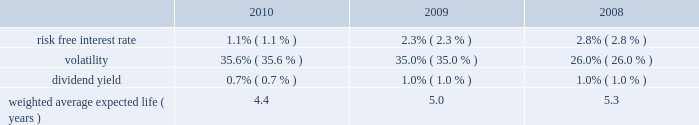The weighted average fair value of options granted during 2010 , 2009 and 2008 was estimated to be $ 7.84 , $ 7.18 and $ 3.84 , respectively , using the black-scholes option pricing model with the assumptions below: .
At december 31 , 2010 and 2009 , the total unrecognized compensation cost related to non-vested stock awards is $ 129.3 million and $ 93.5 million , respectively , which is expected to be recognized in pre-tax income over a weighted average period of 1.7 years as of both year ends .
The company granted a total of 1.5 million restricted stock awards at prices ranging from $ 25.76 to $ 28.15 on various dates in 2010 .
These awards vest annually over three years .
The company also granted 0.9 million performance restricted stock units during 2010 .
These performance restricted stock units have been granted at the maximum achievable level and the number of shares that can vest is based on specific revenue and ebitda goals for periods from 2010 through 2012 .
During 2009 , we granted 0.5 million shares of restricted stock at a price of $ 22.55 that vest annually over 3 years .
On october 1 , 2009 , the company granted 0.4 million restricted stock units at a price of $ 24.85 per share that vested over six months .
On march 20 , 2008 , we granted 0.4 million shares of restricted stock at a price of $ 38.75 that were to vest quarterly over 2 years .
On july 2 , 2008 , 0.2 million of these shares were canceled and assumed by lps .
The remaining unvested restricted shares were converted by the conversion factor of 1.7952 .
These awards vested as of october 1 , 2009 , under the change in control provisions due to the metavante acquisition .
On october 27 , 2008 , we granted 0.8 million shares of restricted stock at a price of $ 14.35 that vest annually over 3 years .
As of december 31 , 2010 and 2009 , we have approximately 2.2 million and 1.4 million unvested restricted shares remaining .
As of december 31 , 2010 we also have 0.6 million of restricted stock units that have not vested .
Share repurchase plans on october 25 , 2006 , our board of directors approved a plan authorizing repurchases of up to $ 200.0 million worth of our common stock ( the 201cold plan 201d ) .
On april 17 , 2008 , our board of directors approved a plan authorizing repurchases of up to an additional $ 250.0 million worth of our common stock ( the 201cnew plan 201d ) .
Under the new plan we repurchased 5.8 million shares of our stock for $ 226.2 million , at an average price of $ 38.97 for the year ended december 31 , 2008 .
During the year ended december 31 , 2008 , we also repurchased an additional 0.2 million shares of our stock for $ 10.0 million at an average price of $ 40.56 under the old plan .
During 2007 , the company repurchased 1.6 million shares at an average price of $ 49.15 under the old plan .
On february 4 , 2010 our board of directors approved a plan authorizing repurchases of up to 15.0 million shares of our common stock in the open market , at prevailing market prices or in privately negotiated transactions , through january 31 , 2013 .
We repurchased 1.4 million shares of our common stock for $ 32.2 million , at an average price of $ 22.97 through march 31 , 2010 .
No additional shares were repurchased under this plan during the year ended december 31 , 2010 .
Approximately 13.6 million shares of our common stock remain available to repurchase under this plan as of december 31 , 2010 .
On may 25 , 2010 , our board of directors authorized a leveraged recapitalization plan to repurchase up to $ 2.5 billion of our common stock at a price range of $ 29.00 2014 $ 31.00 per share of common stock through a modified 201cdutch auction 201d tender offer ( the 201ctender offer 201d ) .
The tender offer commenced on july 6 , 2010 and expired on august 3 , 2010 .
The tender offer was oversubscribed at $ 29.00 , resulting in the purchase of 86.2 million shares , including 6.4 million shares underlying previously unexercised stock options .
The repurchased shares were added to treasury stock .
Fidelity national information services , inc .
And subsidiaries notes to consolidated financial statements 2014 ( continued ) %%transmsg*** transmitting job : g26369 pcn : 087000000 ***%%pcmsg|87 |00008|yes|no|03/28/2011 17:32|0|0|page is valid , no graphics -- color : n| .
What is the percentage change in the fair value of the options from 2009 to 2010? 
Computations: ((7.84 - 7.18) / 7.18)
Answer: 0.09192. 